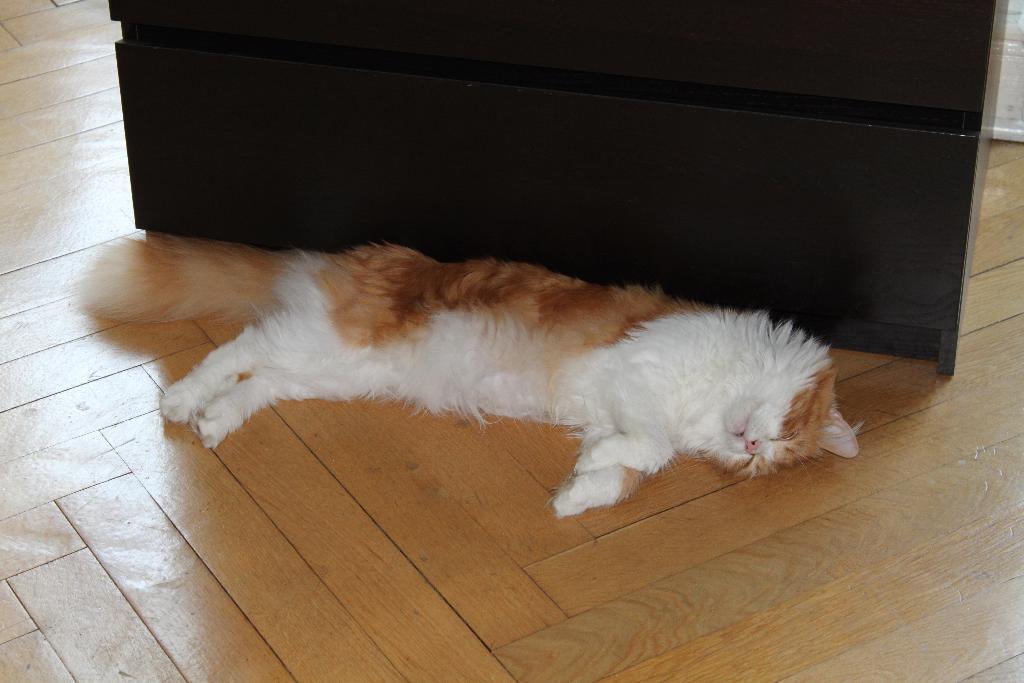In one or two sentences, can you explain what this image depicts? In this image I can see a cat sleeping on the floor and the cat is in white and brown color. Background I can see some object in brown color. 